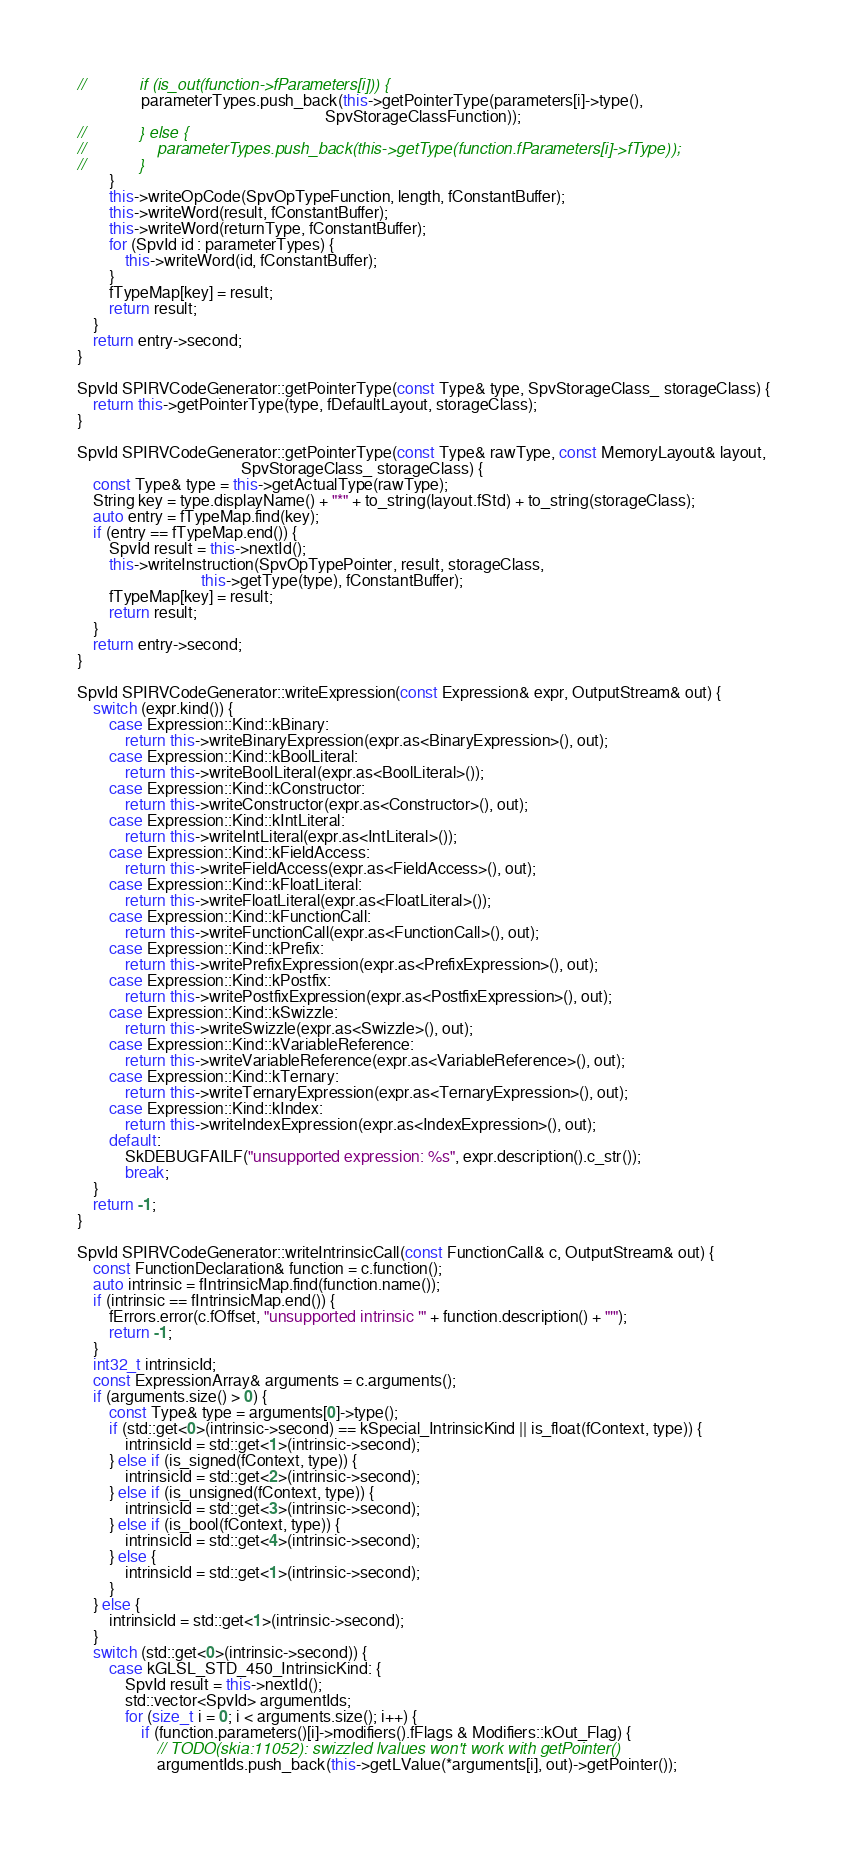Convert code to text. <code><loc_0><loc_0><loc_500><loc_500><_C++_>//            if (is_out(function->fParameters[i])) {
                parameterTypes.push_back(this->getPointerType(parameters[i]->type(),
                                                              SpvStorageClassFunction));
//            } else {
//                parameterTypes.push_back(this->getType(function.fParameters[i]->fType));
//            }
        }
        this->writeOpCode(SpvOpTypeFunction, length, fConstantBuffer);
        this->writeWord(result, fConstantBuffer);
        this->writeWord(returnType, fConstantBuffer);
        for (SpvId id : parameterTypes) {
            this->writeWord(id, fConstantBuffer);
        }
        fTypeMap[key] = result;
        return result;
    }
    return entry->second;
}

SpvId SPIRVCodeGenerator::getPointerType(const Type& type, SpvStorageClass_ storageClass) {
    return this->getPointerType(type, fDefaultLayout, storageClass);
}

SpvId SPIRVCodeGenerator::getPointerType(const Type& rawType, const MemoryLayout& layout,
                                         SpvStorageClass_ storageClass) {
    const Type& type = this->getActualType(rawType);
    String key = type.displayName() + "*" + to_string(layout.fStd) + to_string(storageClass);
    auto entry = fTypeMap.find(key);
    if (entry == fTypeMap.end()) {
        SpvId result = this->nextId();
        this->writeInstruction(SpvOpTypePointer, result, storageClass,
                               this->getType(type), fConstantBuffer);
        fTypeMap[key] = result;
        return result;
    }
    return entry->second;
}

SpvId SPIRVCodeGenerator::writeExpression(const Expression& expr, OutputStream& out) {
    switch (expr.kind()) {
        case Expression::Kind::kBinary:
            return this->writeBinaryExpression(expr.as<BinaryExpression>(), out);
        case Expression::Kind::kBoolLiteral:
            return this->writeBoolLiteral(expr.as<BoolLiteral>());
        case Expression::Kind::kConstructor:
            return this->writeConstructor(expr.as<Constructor>(), out);
        case Expression::Kind::kIntLiteral:
            return this->writeIntLiteral(expr.as<IntLiteral>());
        case Expression::Kind::kFieldAccess:
            return this->writeFieldAccess(expr.as<FieldAccess>(), out);
        case Expression::Kind::kFloatLiteral:
            return this->writeFloatLiteral(expr.as<FloatLiteral>());
        case Expression::Kind::kFunctionCall:
            return this->writeFunctionCall(expr.as<FunctionCall>(), out);
        case Expression::Kind::kPrefix:
            return this->writePrefixExpression(expr.as<PrefixExpression>(), out);
        case Expression::Kind::kPostfix:
            return this->writePostfixExpression(expr.as<PostfixExpression>(), out);
        case Expression::Kind::kSwizzle:
            return this->writeSwizzle(expr.as<Swizzle>(), out);
        case Expression::Kind::kVariableReference:
            return this->writeVariableReference(expr.as<VariableReference>(), out);
        case Expression::Kind::kTernary:
            return this->writeTernaryExpression(expr.as<TernaryExpression>(), out);
        case Expression::Kind::kIndex:
            return this->writeIndexExpression(expr.as<IndexExpression>(), out);
        default:
            SkDEBUGFAILF("unsupported expression: %s", expr.description().c_str());
            break;
    }
    return -1;
}

SpvId SPIRVCodeGenerator::writeIntrinsicCall(const FunctionCall& c, OutputStream& out) {
    const FunctionDeclaration& function = c.function();
    auto intrinsic = fIntrinsicMap.find(function.name());
    if (intrinsic == fIntrinsicMap.end()) {
        fErrors.error(c.fOffset, "unsupported intrinsic '" + function.description() + "'");
        return -1;
    }
    int32_t intrinsicId;
    const ExpressionArray& arguments = c.arguments();
    if (arguments.size() > 0) {
        const Type& type = arguments[0]->type();
        if (std::get<0>(intrinsic->second) == kSpecial_IntrinsicKind || is_float(fContext, type)) {
            intrinsicId = std::get<1>(intrinsic->second);
        } else if (is_signed(fContext, type)) {
            intrinsicId = std::get<2>(intrinsic->second);
        } else if (is_unsigned(fContext, type)) {
            intrinsicId = std::get<3>(intrinsic->second);
        } else if (is_bool(fContext, type)) {
            intrinsicId = std::get<4>(intrinsic->second);
        } else {
            intrinsicId = std::get<1>(intrinsic->second);
        }
    } else {
        intrinsicId = std::get<1>(intrinsic->second);
    }
    switch (std::get<0>(intrinsic->second)) {
        case kGLSL_STD_450_IntrinsicKind: {
            SpvId result = this->nextId();
            std::vector<SpvId> argumentIds;
            for (size_t i = 0; i < arguments.size(); i++) {
                if (function.parameters()[i]->modifiers().fFlags & Modifiers::kOut_Flag) {
                    // TODO(skia:11052): swizzled lvalues won't work with getPointer()
                    argumentIds.push_back(this->getLValue(*arguments[i], out)->getPointer());</code> 